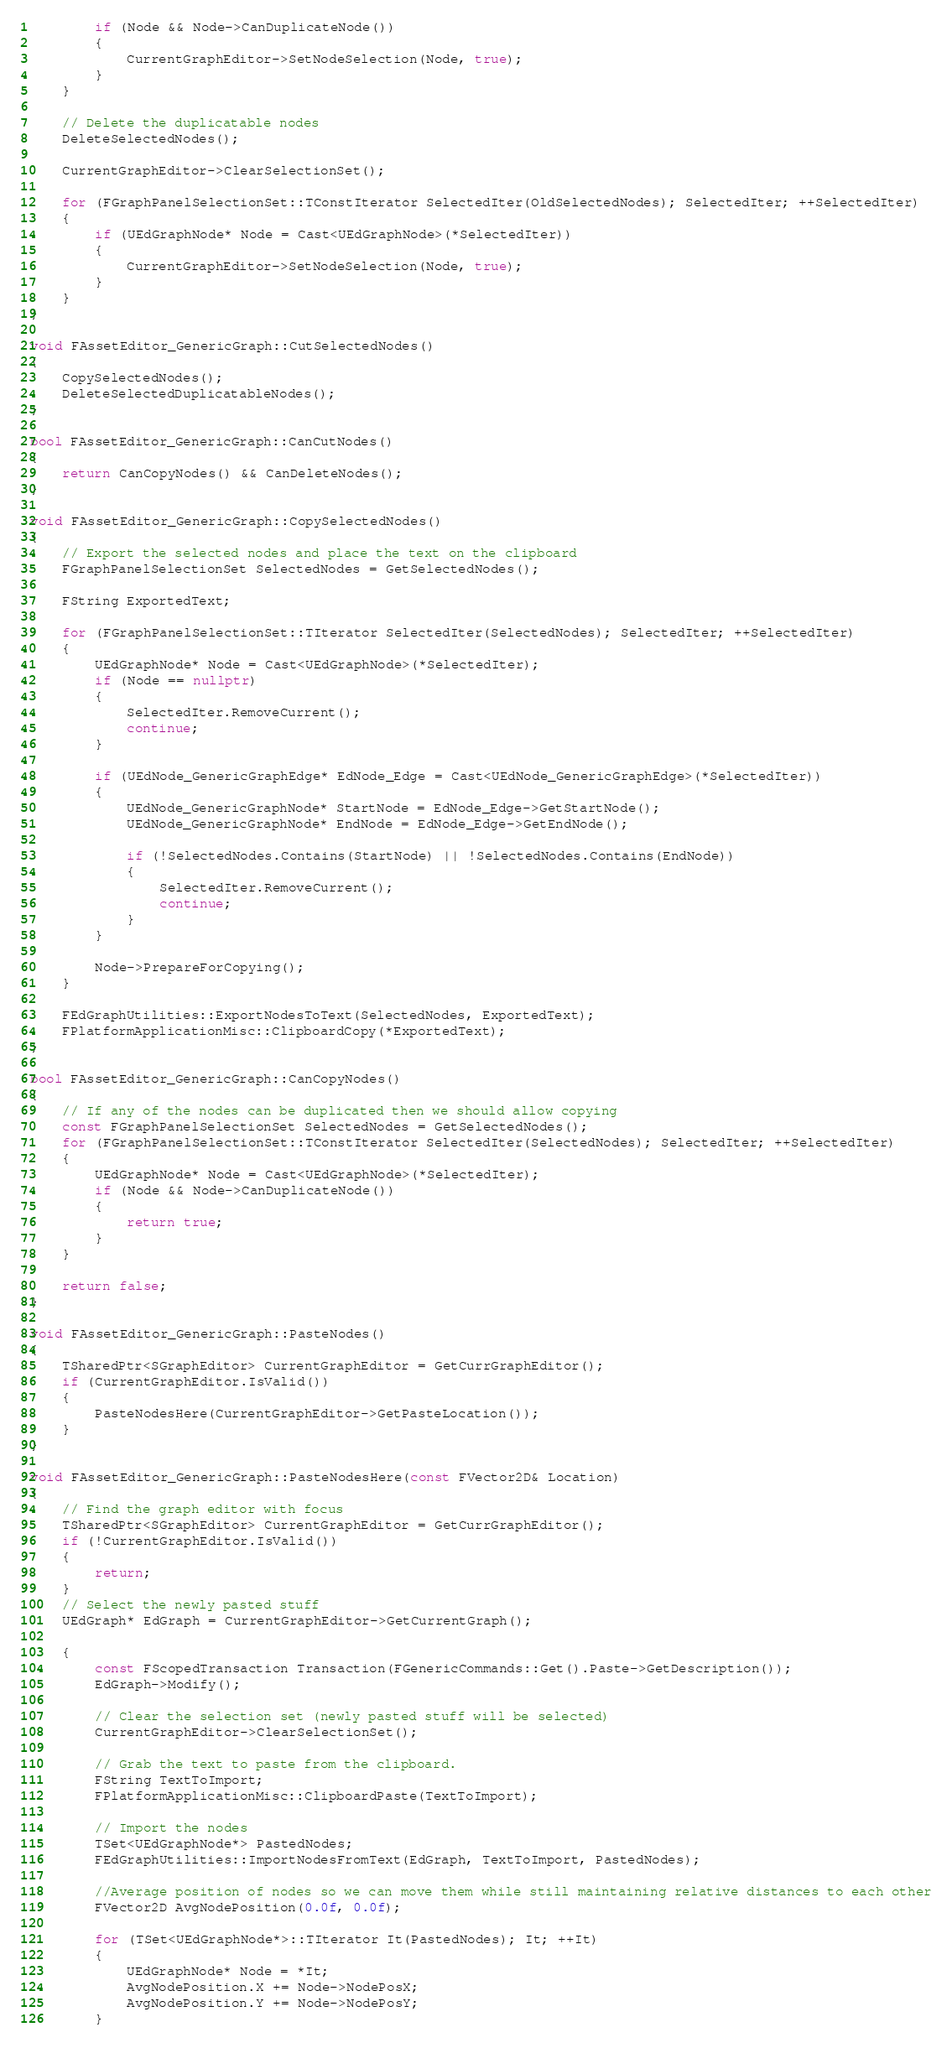Convert code to text. <code><loc_0><loc_0><loc_500><loc_500><_C++_>		if (Node && Node->CanDuplicateNode())
		{
			CurrentGraphEditor->SetNodeSelection(Node, true);
		}
	}

	// Delete the duplicatable nodes
	DeleteSelectedNodes();

	CurrentGraphEditor->ClearSelectionSet();

	for (FGraphPanelSelectionSet::TConstIterator SelectedIter(OldSelectedNodes); SelectedIter; ++SelectedIter)
	{
		if (UEdGraphNode* Node = Cast<UEdGraphNode>(*SelectedIter))
		{
			CurrentGraphEditor->SetNodeSelection(Node, true);
		}
	}
}

void FAssetEditor_GenericGraph::CutSelectedNodes()
{
	CopySelectedNodes();
	DeleteSelectedDuplicatableNodes();
}

bool FAssetEditor_GenericGraph::CanCutNodes()
{
	return CanCopyNodes() && CanDeleteNodes();
}

void FAssetEditor_GenericGraph::CopySelectedNodes()
{
	// Export the selected nodes and place the text on the clipboard
	FGraphPanelSelectionSet SelectedNodes = GetSelectedNodes();

	FString ExportedText;

	for (FGraphPanelSelectionSet::TIterator SelectedIter(SelectedNodes); SelectedIter; ++SelectedIter)
	{
		UEdGraphNode* Node = Cast<UEdGraphNode>(*SelectedIter);
		if (Node == nullptr)
		{
			SelectedIter.RemoveCurrent();
			continue;
		}

		if (UEdNode_GenericGraphEdge* EdNode_Edge = Cast<UEdNode_GenericGraphEdge>(*SelectedIter))
		{
			UEdNode_GenericGraphNode* StartNode = EdNode_Edge->GetStartNode();
			UEdNode_GenericGraphNode* EndNode = EdNode_Edge->GetEndNode();

			if (!SelectedNodes.Contains(StartNode) || !SelectedNodes.Contains(EndNode))
			{
				SelectedIter.RemoveCurrent();
				continue;
			}
		}

		Node->PrepareForCopying();
	}

	FEdGraphUtilities::ExportNodesToText(SelectedNodes, ExportedText);
	FPlatformApplicationMisc::ClipboardCopy(*ExportedText);
}

bool FAssetEditor_GenericGraph::CanCopyNodes()
{
	// If any of the nodes can be duplicated then we should allow copying
	const FGraphPanelSelectionSet SelectedNodes = GetSelectedNodes();
	for (FGraphPanelSelectionSet::TConstIterator SelectedIter(SelectedNodes); SelectedIter; ++SelectedIter)
	{
		UEdGraphNode* Node = Cast<UEdGraphNode>(*SelectedIter);
		if (Node && Node->CanDuplicateNode())
		{
			return true;
		}
	}

	return false;
}

void FAssetEditor_GenericGraph::PasteNodes()
{
	TSharedPtr<SGraphEditor> CurrentGraphEditor = GetCurrGraphEditor();
	if (CurrentGraphEditor.IsValid())
	{
		PasteNodesHere(CurrentGraphEditor->GetPasteLocation());
	}
}

void FAssetEditor_GenericGraph::PasteNodesHere(const FVector2D& Location)
{
	// Find the graph editor with focus
	TSharedPtr<SGraphEditor> CurrentGraphEditor = GetCurrGraphEditor();
	if (!CurrentGraphEditor.IsValid())
	{
		return;
	}
	// Select the newly pasted stuff
	UEdGraph* EdGraph = CurrentGraphEditor->GetCurrentGraph();

	{
		const FScopedTransaction Transaction(FGenericCommands::Get().Paste->GetDescription());
		EdGraph->Modify();

		// Clear the selection set (newly pasted stuff will be selected)
		CurrentGraphEditor->ClearSelectionSet();

		// Grab the text to paste from the clipboard.
		FString TextToImport;
		FPlatformApplicationMisc::ClipboardPaste(TextToImport);

		// Import the nodes
		TSet<UEdGraphNode*> PastedNodes;
		FEdGraphUtilities::ImportNodesFromText(EdGraph, TextToImport, PastedNodes);

		//Average position of nodes so we can move them while still maintaining relative distances to each other
		FVector2D AvgNodePosition(0.0f, 0.0f);

		for (TSet<UEdGraphNode*>::TIterator It(PastedNodes); It; ++It)
		{
			UEdGraphNode* Node = *It;
			AvgNodePosition.X += Node->NodePosX;
			AvgNodePosition.Y += Node->NodePosY;
		}</code> 